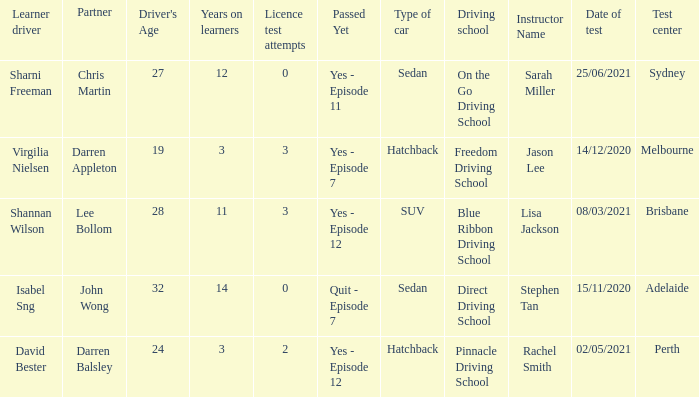Which driver is older than 24 and has more than 0 licence test attempts? Shannan Wilson. 